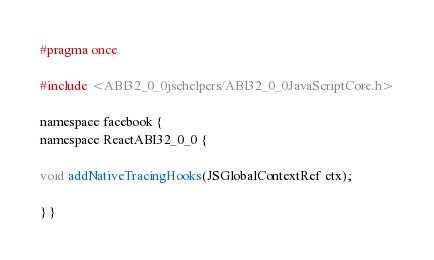Convert code to text. <code><loc_0><loc_0><loc_500><loc_500><_C_>
#pragma once

#include <ABI32_0_0jschelpers/ABI32_0_0JavaScriptCore.h>

namespace facebook {
namespace ReactABI32_0_0 {

void addNativeTracingHooks(JSGlobalContextRef ctx);

} }
</code> 